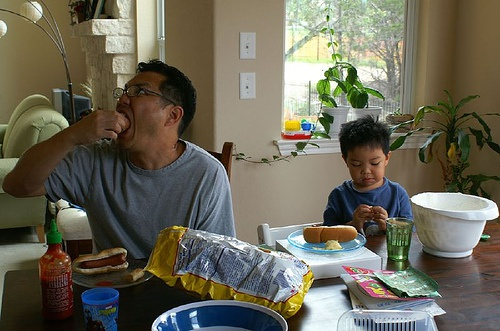Describe the objects in this image and their specific colors. I can see dining table in olive, black, gray, lightgray, and darkgray tones, people in olive, black, gray, and maroon tones, people in olive, black, maroon, gray, and darkblue tones, potted plant in olive, darkgray, beige, and darkgreen tones, and potted plant in olive, black, darkgreen, and gray tones in this image. 